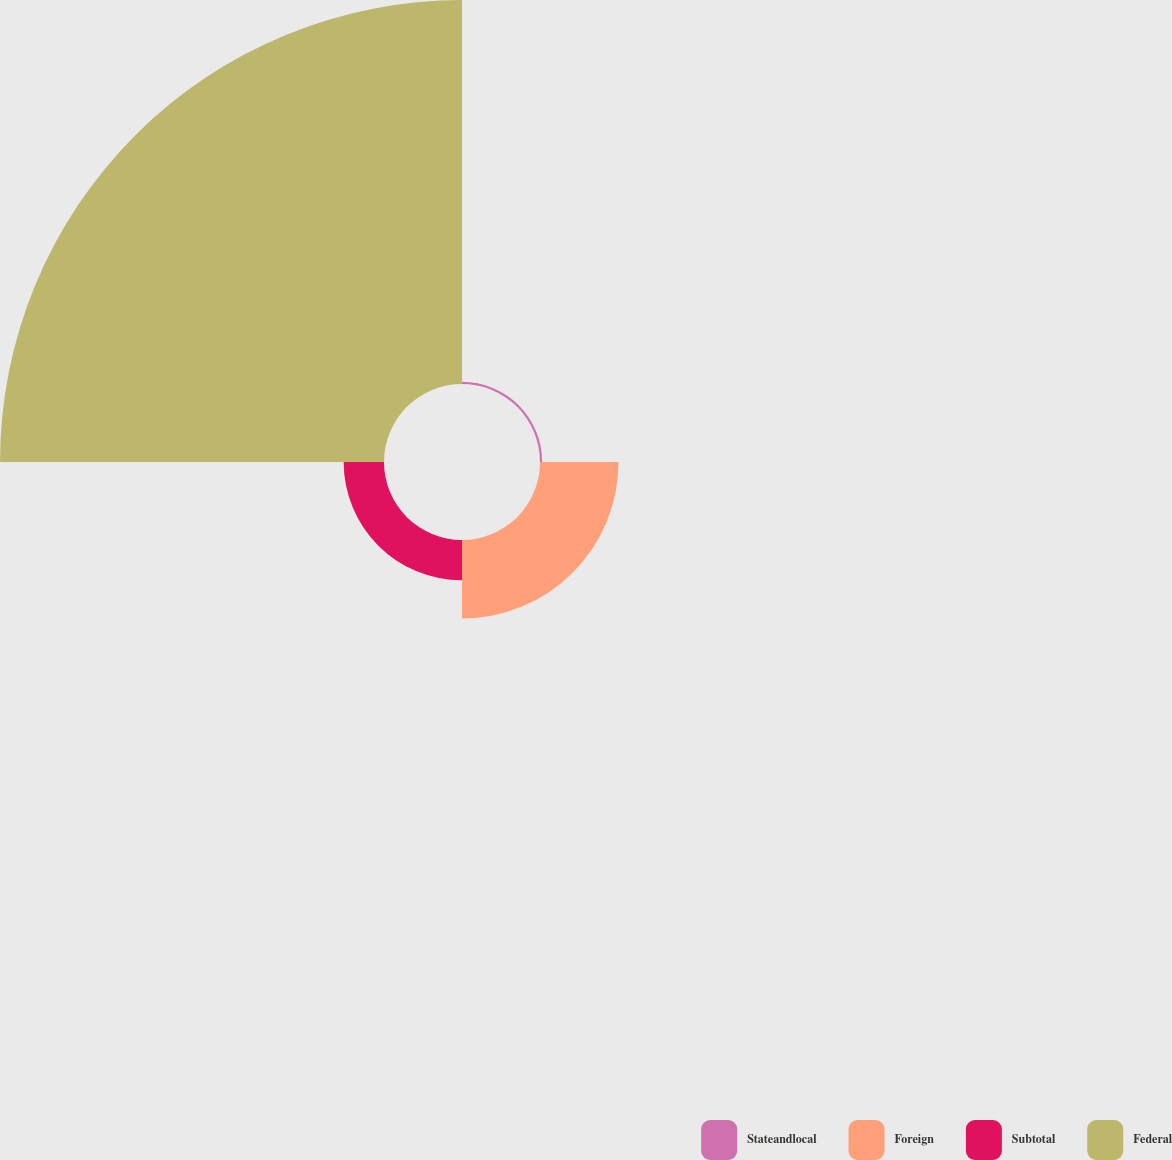Convert chart. <chart><loc_0><loc_0><loc_500><loc_500><pie_chart><fcel>Stateandlocal<fcel>Foreign<fcel>Subtotal<fcel>Federal<nl><fcel>0.43%<fcel>15.55%<fcel>7.99%<fcel>76.04%<nl></chart> 